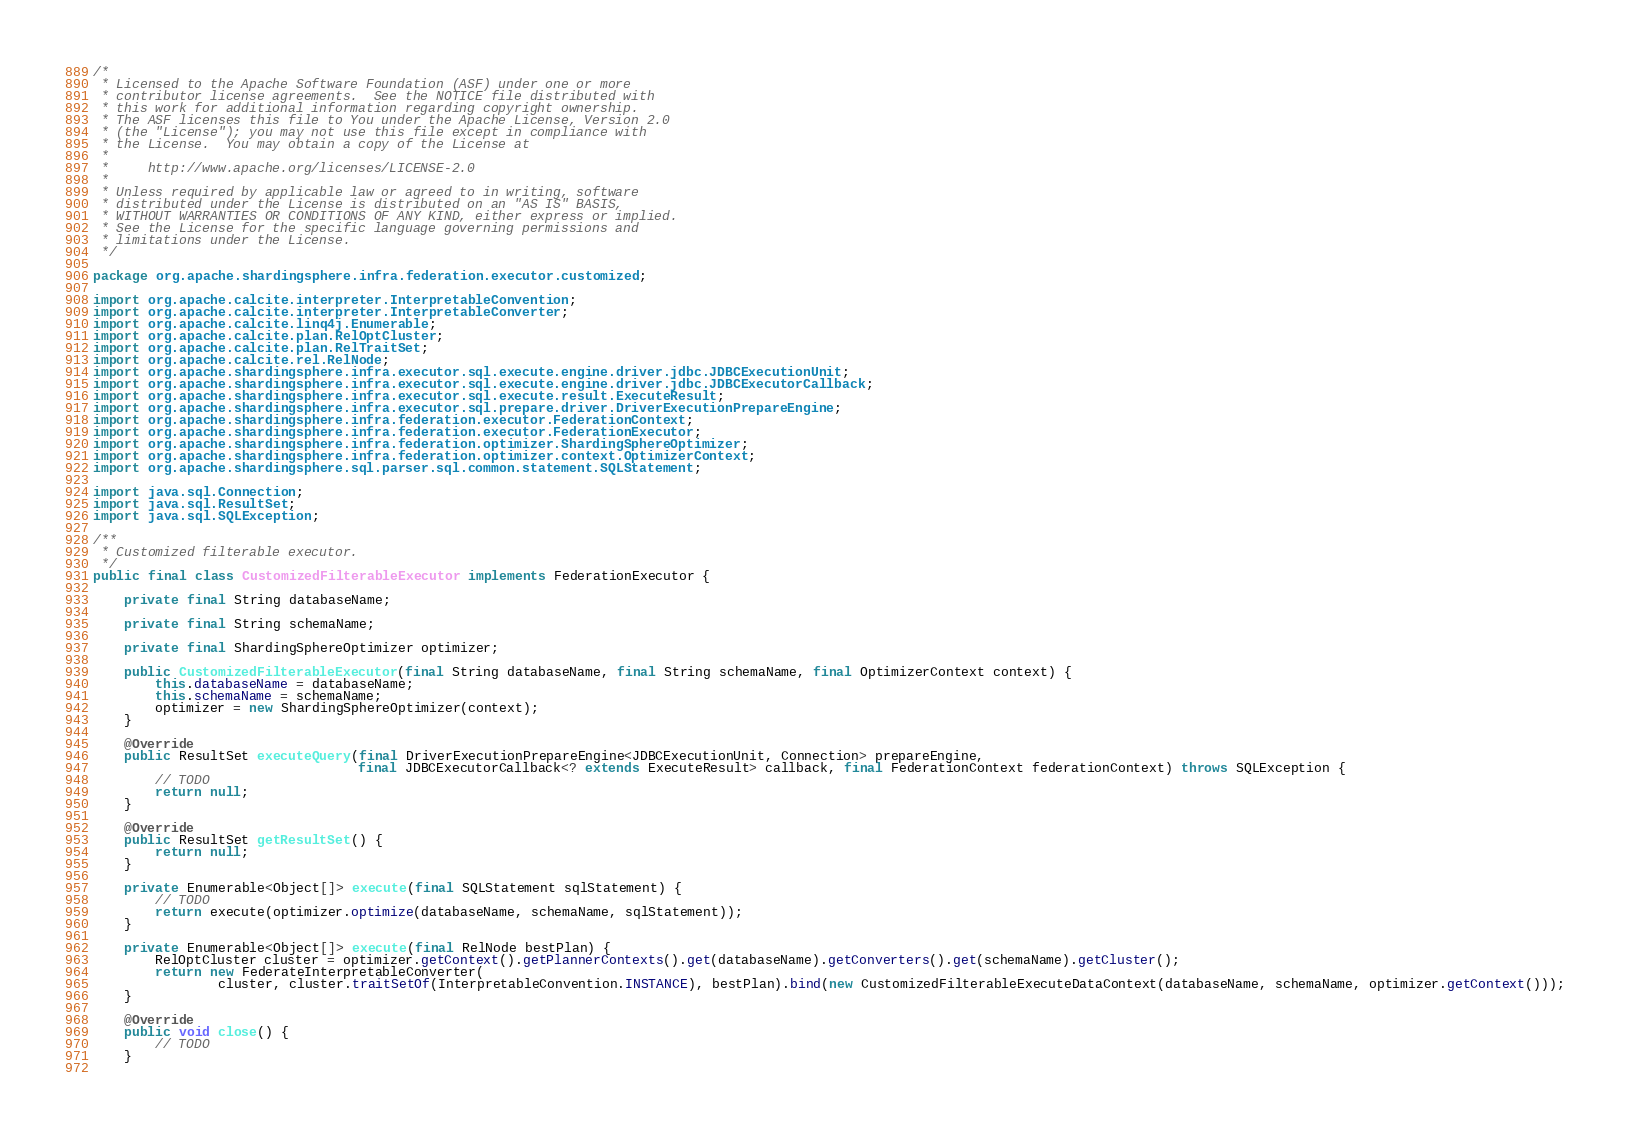<code> <loc_0><loc_0><loc_500><loc_500><_Java_>/*
 * Licensed to the Apache Software Foundation (ASF) under one or more
 * contributor license agreements.  See the NOTICE file distributed with
 * this work for additional information regarding copyright ownership.
 * The ASF licenses this file to You under the Apache License, Version 2.0
 * (the "License"); you may not use this file except in compliance with
 * the License.  You may obtain a copy of the License at
 *
 *     http://www.apache.org/licenses/LICENSE-2.0
 *
 * Unless required by applicable law or agreed to in writing, software
 * distributed under the License is distributed on an "AS IS" BASIS,
 * WITHOUT WARRANTIES OR CONDITIONS OF ANY KIND, either express or implied.
 * See the License for the specific language governing permissions and
 * limitations under the License.
 */

package org.apache.shardingsphere.infra.federation.executor.customized;

import org.apache.calcite.interpreter.InterpretableConvention;
import org.apache.calcite.interpreter.InterpretableConverter;
import org.apache.calcite.linq4j.Enumerable;
import org.apache.calcite.plan.RelOptCluster;
import org.apache.calcite.plan.RelTraitSet;
import org.apache.calcite.rel.RelNode;
import org.apache.shardingsphere.infra.executor.sql.execute.engine.driver.jdbc.JDBCExecutionUnit;
import org.apache.shardingsphere.infra.executor.sql.execute.engine.driver.jdbc.JDBCExecutorCallback;
import org.apache.shardingsphere.infra.executor.sql.execute.result.ExecuteResult;
import org.apache.shardingsphere.infra.executor.sql.prepare.driver.DriverExecutionPrepareEngine;
import org.apache.shardingsphere.infra.federation.executor.FederationContext;
import org.apache.shardingsphere.infra.federation.executor.FederationExecutor;
import org.apache.shardingsphere.infra.federation.optimizer.ShardingSphereOptimizer;
import org.apache.shardingsphere.infra.federation.optimizer.context.OptimizerContext;
import org.apache.shardingsphere.sql.parser.sql.common.statement.SQLStatement;

import java.sql.Connection;
import java.sql.ResultSet;
import java.sql.SQLException;

/**
 * Customized filterable executor.
 */
public final class CustomizedFilterableExecutor implements FederationExecutor {
    
    private final String databaseName;
    
    private final String schemaName;
    
    private final ShardingSphereOptimizer optimizer;
    
    public CustomizedFilterableExecutor(final String databaseName, final String schemaName, final OptimizerContext context) {
        this.databaseName = databaseName;
        this.schemaName = schemaName;
        optimizer = new ShardingSphereOptimizer(context);
    }
    
    @Override
    public ResultSet executeQuery(final DriverExecutionPrepareEngine<JDBCExecutionUnit, Connection> prepareEngine,
                                  final JDBCExecutorCallback<? extends ExecuteResult> callback, final FederationContext federationContext) throws SQLException {
        // TODO
        return null;
    }
    
    @Override
    public ResultSet getResultSet() {
        return null;
    }
    
    private Enumerable<Object[]> execute(final SQLStatement sqlStatement) {
        // TODO
        return execute(optimizer.optimize(databaseName, schemaName, sqlStatement));
    }
    
    private Enumerable<Object[]> execute(final RelNode bestPlan) {
        RelOptCluster cluster = optimizer.getContext().getPlannerContexts().get(databaseName).getConverters().get(schemaName).getCluster();
        return new FederateInterpretableConverter(
                cluster, cluster.traitSetOf(InterpretableConvention.INSTANCE), bestPlan).bind(new CustomizedFilterableExecuteDataContext(databaseName, schemaName, optimizer.getContext()));
    }
    
    @Override
    public void close() {
        // TODO
    }
    </code> 